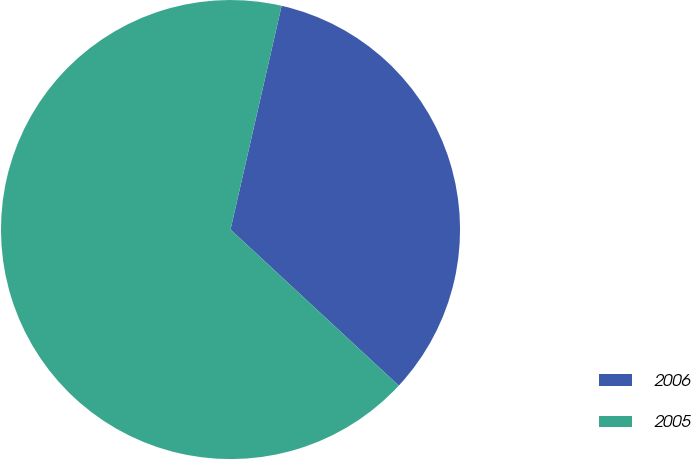Convert chart to OTSL. <chart><loc_0><loc_0><loc_500><loc_500><pie_chart><fcel>2006<fcel>2005<nl><fcel>33.33%<fcel>66.67%<nl></chart> 